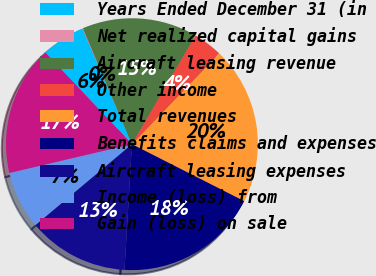Convert chart. <chart><loc_0><loc_0><loc_500><loc_500><pie_chart><fcel>Years Ended December 31 (in<fcel>Net realized capital gains<fcel>Aircraft leasing revenue<fcel>Other income<fcel>Total revenues<fcel>Benefits claims and expenses<fcel>Aircraft leasing expenses<fcel>Income (loss) from<fcel>Gain (loss) on sale<nl><fcel>5.6%<fcel>0.09%<fcel>14.78%<fcel>3.76%<fcel>20.29%<fcel>18.46%<fcel>12.95%<fcel>7.44%<fcel>16.62%<nl></chart> 